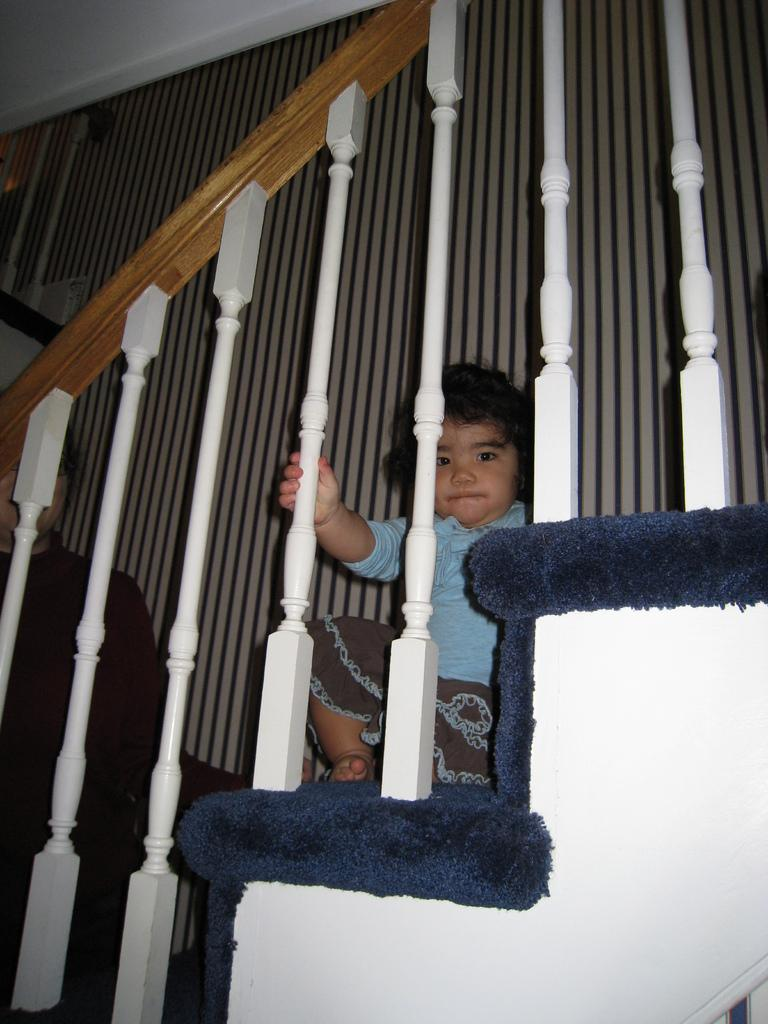What is the main subject of the image? The main subject of the image is a kid. Where is the kid located in the image? The kid is on a staircase. What can be seen near the kid in the image? There is a railing in the image. What is visible in the background of the image? There is a wall in the background of the image. What type of spy equipment can be seen in the image? There is no spy equipment present in the image. Who is the creator of the staircase in the image? The creator of the staircase is not mentioned in the image. 